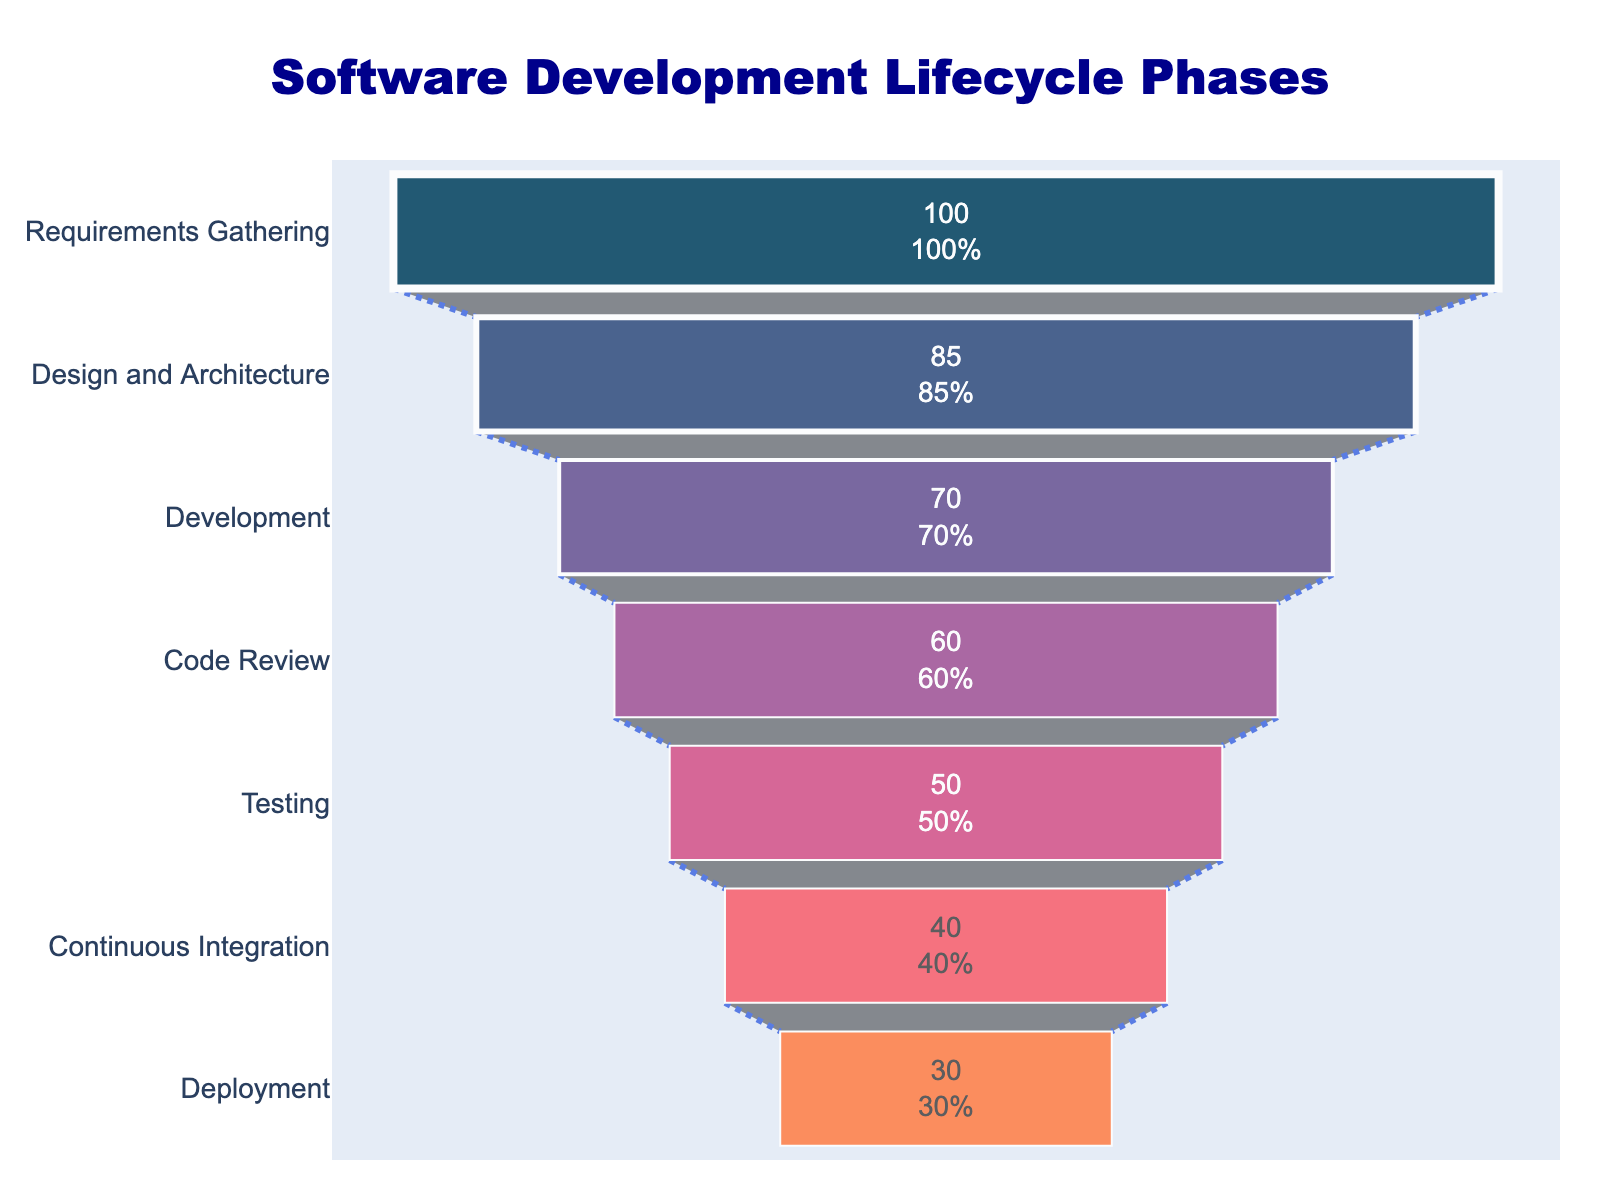What is the title of the figure? The title of the figure is displayed at the top and reads "Software Development Lifecycle Phases".
Answer: Software Development Lifecycle Phases How many phases are shown in the funnel chart? The funnel chart displays a list of the phases from top to bottom. Counting each phase listed visually will reveal there are seven phases shown.
Answer: Seven Which phase has the highest value? The phase with the highest value is located at the widest section of the funnel chart. "Requirements Gathering" has the highest value of 100.
Answer: Requirements Gathering What is the value associated with the deployment phase? The deployment phase is the last phase listed at the bottom of the funnel, and the chart indicates its value is 30.
Answer: 30 Which two phases have the closest values, and what are their values? Compare adjacent values displayed beside each phase to find the closest pair. "Code Review" has a value of 60 and "Testing" has a value of 50, which are closest with a difference of 10.
Answer: Code Review and Testing, 60 and 50 By what percentage does the value decrease from Requirements Gathering to Design and Architecture? First, calculate the difference: 100 - 85 = 15. Then, determine the percentage decrease: (15 / 100) * 100 = 15%.
Answer: 15% Which phase has the smallest value and what is the value? The smallest value is located at the narrowest part of the funnel chart. "Deployment" is the phase with the smallest value, which is 30.
Answer: Deployment, 30 How does the value change from the Testing phase to the Continuous Integration phase? Analyze the two values: Testing (50) and Continuous Integration (40). The value decreases by 10.
Answer: Decreases by 10 What is the overall trend observed in the values from the first phase to the last phase? The values decrease throughout the phases from Requirements Gathering (100) to Deployment (30), indicating a consistently downward trend.
Answer: Downward trend What is the cumulative value of the Development, Code Review, and Testing phases? Sum the values of the Development (70), Code Review (60), and Testing (50) phases: 70 + 60 + 50 = 180.
Answer: 180 